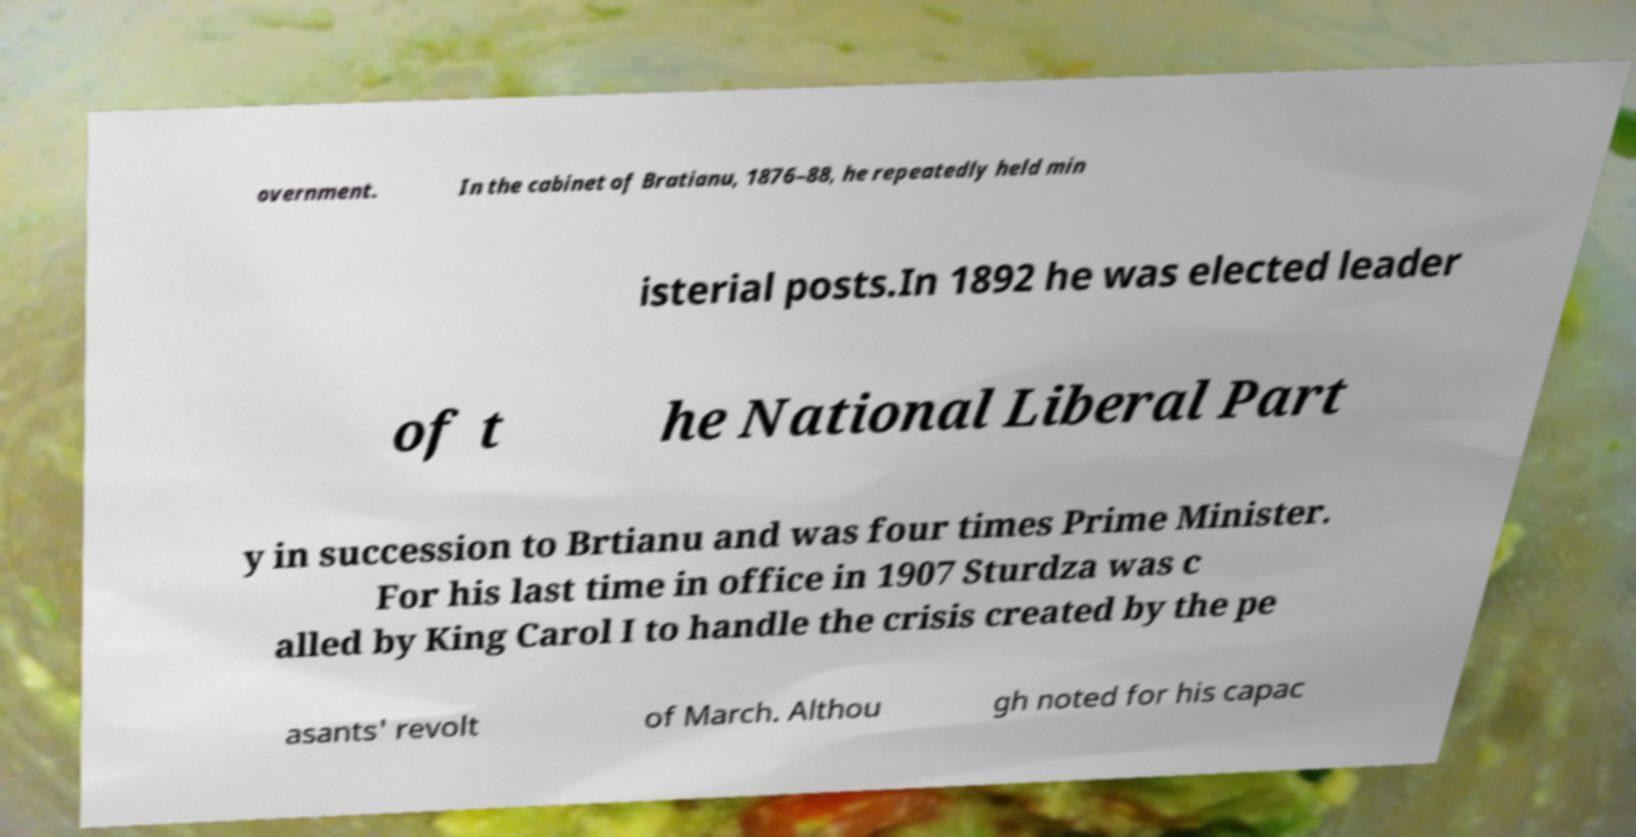Please read and relay the text visible in this image. What does it say? overnment. In the cabinet of Bratianu, 1876–88, he repeatedly held min isterial posts.In 1892 he was elected leader of t he National Liberal Part y in succession to Brtianu and was four times Prime Minister. For his last time in office in 1907 Sturdza was c alled by King Carol I to handle the crisis created by the pe asants' revolt of March. Althou gh noted for his capac 